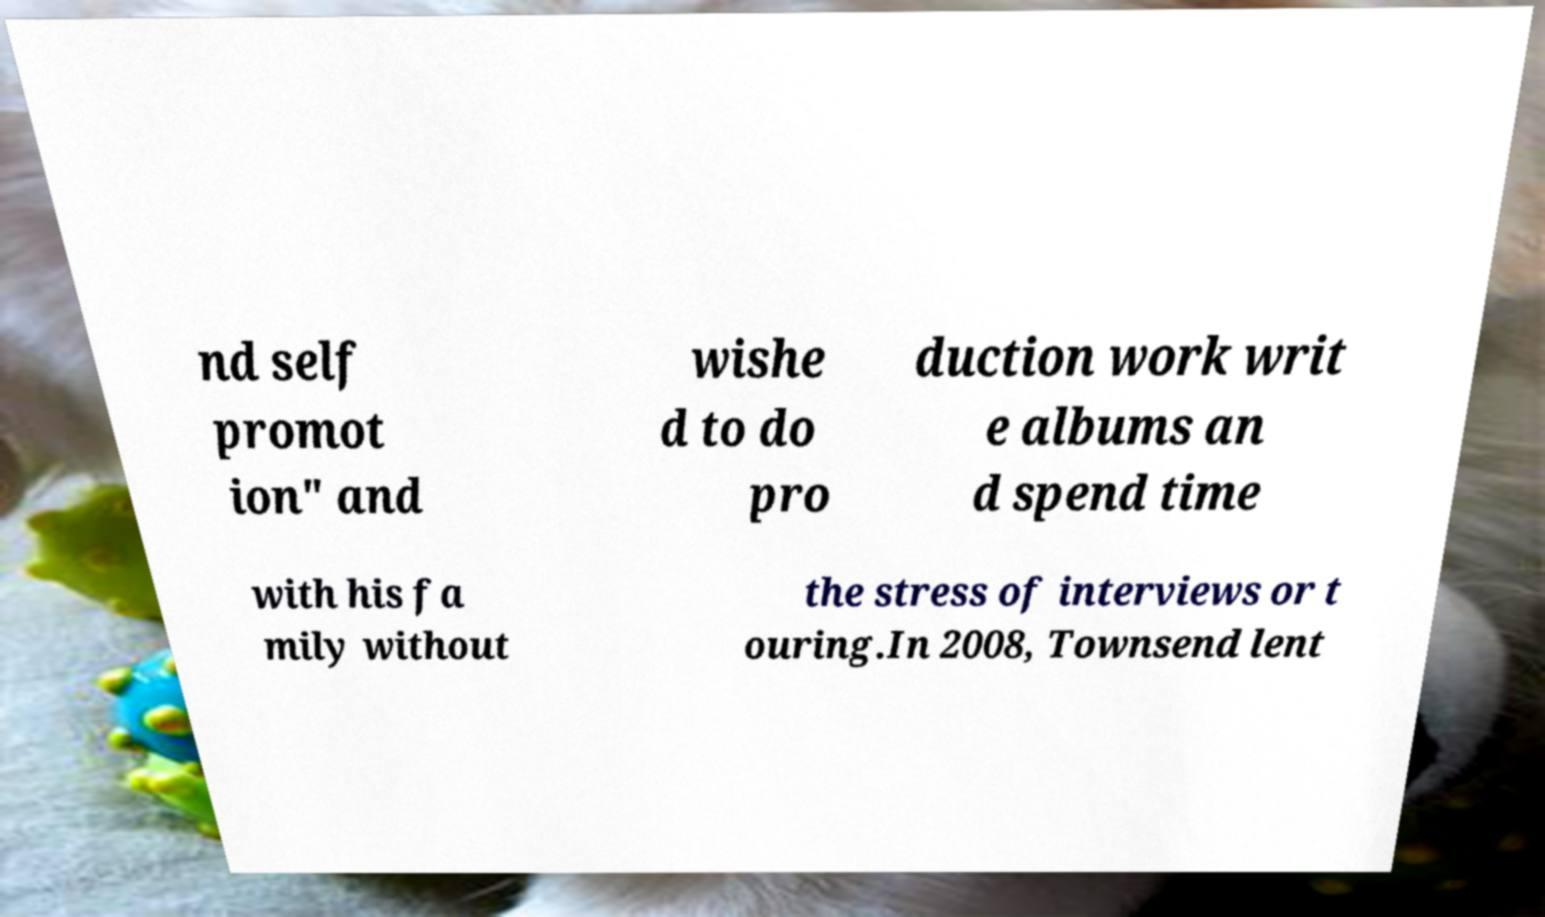Please read and relay the text visible in this image. What does it say? nd self promot ion" and wishe d to do pro duction work writ e albums an d spend time with his fa mily without the stress of interviews or t ouring.In 2008, Townsend lent 